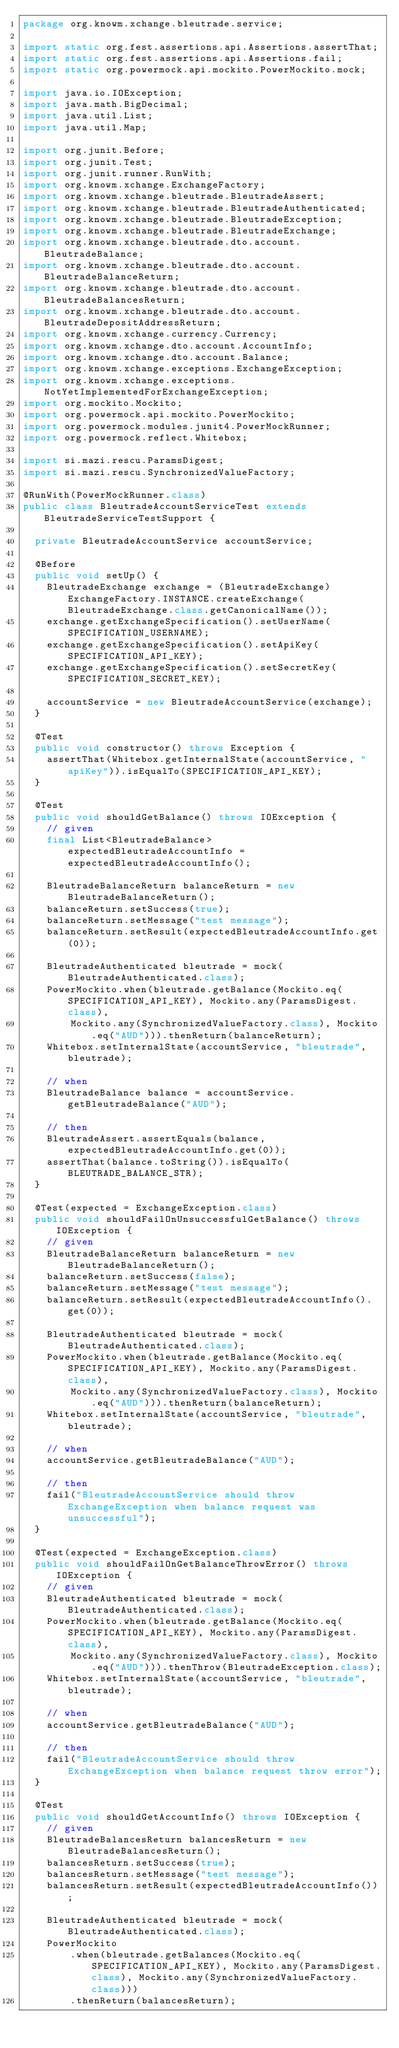<code> <loc_0><loc_0><loc_500><loc_500><_Java_>package org.knowm.xchange.bleutrade.service;

import static org.fest.assertions.api.Assertions.assertThat;
import static org.fest.assertions.api.Assertions.fail;
import static org.powermock.api.mockito.PowerMockito.mock;

import java.io.IOException;
import java.math.BigDecimal;
import java.util.List;
import java.util.Map;

import org.junit.Before;
import org.junit.Test;
import org.junit.runner.RunWith;
import org.knowm.xchange.ExchangeFactory;
import org.knowm.xchange.bleutrade.BleutradeAssert;
import org.knowm.xchange.bleutrade.BleutradeAuthenticated;
import org.knowm.xchange.bleutrade.BleutradeException;
import org.knowm.xchange.bleutrade.BleutradeExchange;
import org.knowm.xchange.bleutrade.dto.account.BleutradeBalance;
import org.knowm.xchange.bleutrade.dto.account.BleutradeBalanceReturn;
import org.knowm.xchange.bleutrade.dto.account.BleutradeBalancesReturn;
import org.knowm.xchange.bleutrade.dto.account.BleutradeDepositAddressReturn;
import org.knowm.xchange.currency.Currency;
import org.knowm.xchange.dto.account.AccountInfo;
import org.knowm.xchange.dto.account.Balance;
import org.knowm.xchange.exceptions.ExchangeException;
import org.knowm.xchange.exceptions.NotYetImplementedForExchangeException;
import org.mockito.Mockito;
import org.powermock.api.mockito.PowerMockito;
import org.powermock.modules.junit4.PowerMockRunner;
import org.powermock.reflect.Whitebox;

import si.mazi.rescu.ParamsDigest;
import si.mazi.rescu.SynchronizedValueFactory;

@RunWith(PowerMockRunner.class)
public class BleutradeAccountServiceTest extends BleutradeServiceTestSupport {

  private BleutradeAccountService accountService;

  @Before
  public void setUp() {
    BleutradeExchange exchange = (BleutradeExchange) ExchangeFactory.INSTANCE.createExchange(BleutradeExchange.class.getCanonicalName());
    exchange.getExchangeSpecification().setUserName(SPECIFICATION_USERNAME);
    exchange.getExchangeSpecification().setApiKey(SPECIFICATION_API_KEY);
    exchange.getExchangeSpecification().setSecretKey(SPECIFICATION_SECRET_KEY);

    accountService = new BleutradeAccountService(exchange);
  }

  @Test
  public void constructor() throws Exception {
    assertThat(Whitebox.getInternalState(accountService, "apiKey")).isEqualTo(SPECIFICATION_API_KEY);
  }

  @Test
  public void shouldGetBalance() throws IOException {
    // given
    final List<BleutradeBalance> expectedBleutradeAccountInfo = expectedBleutradeAccountInfo();

    BleutradeBalanceReturn balanceReturn = new BleutradeBalanceReturn();
    balanceReturn.setSuccess(true);
    balanceReturn.setMessage("test message");
    balanceReturn.setResult(expectedBleutradeAccountInfo.get(0));

    BleutradeAuthenticated bleutrade = mock(BleutradeAuthenticated.class);
    PowerMockito.when(bleutrade.getBalance(Mockito.eq(SPECIFICATION_API_KEY), Mockito.any(ParamsDigest.class),
        Mockito.any(SynchronizedValueFactory.class), Mockito.eq("AUD"))).thenReturn(balanceReturn);
    Whitebox.setInternalState(accountService, "bleutrade", bleutrade);

    // when
    BleutradeBalance balance = accountService.getBleutradeBalance("AUD");

    // then
    BleutradeAssert.assertEquals(balance, expectedBleutradeAccountInfo.get(0));
    assertThat(balance.toString()).isEqualTo(BLEUTRADE_BALANCE_STR);
  }

  @Test(expected = ExchangeException.class)
  public void shouldFailOnUnsuccessfulGetBalance() throws IOException {
    // given
    BleutradeBalanceReturn balanceReturn = new BleutradeBalanceReturn();
    balanceReturn.setSuccess(false);
    balanceReturn.setMessage("test message");
    balanceReturn.setResult(expectedBleutradeAccountInfo().get(0));

    BleutradeAuthenticated bleutrade = mock(BleutradeAuthenticated.class);
    PowerMockito.when(bleutrade.getBalance(Mockito.eq(SPECIFICATION_API_KEY), Mockito.any(ParamsDigest.class),
        Mockito.any(SynchronizedValueFactory.class), Mockito.eq("AUD"))).thenReturn(balanceReturn);
    Whitebox.setInternalState(accountService, "bleutrade", bleutrade);

    // when
    accountService.getBleutradeBalance("AUD");

    // then
    fail("BleutradeAccountService should throw ExchangeException when balance request was unsuccessful");
  }

  @Test(expected = ExchangeException.class)
  public void shouldFailOnGetBalanceThrowError() throws IOException {
    // given
    BleutradeAuthenticated bleutrade = mock(BleutradeAuthenticated.class);
    PowerMockito.when(bleutrade.getBalance(Mockito.eq(SPECIFICATION_API_KEY), Mockito.any(ParamsDigest.class),
        Mockito.any(SynchronizedValueFactory.class), Mockito.eq("AUD"))).thenThrow(BleutradeException.class);
    Whitebox.setInternalState(accountService, "bleutrade", bleutrade);

    // when
    accountService.getBleutradeBalance("AUD");

    // then
    fail("BleutradeAccountService should throw ExchangeException when balance request throw error");
  }

  @Test
  public void shouldGetAccountInfo() throws IOException {
    // given
    BleutradeBalancesReturn balancesReturn = new BleutradeBalancesReturn();
    balancesReturn.setSuccess(true);
    balancesReturn.setMessage("test message");
    balancesReturn.setResult(expectedBleutradeAccountInfo());

    BleutradeAuthenticated bleutrade = mock(BleutradeAuthenticated.class);
    PowerMockito
        .when(bleutrade.getBalances(Mockito.eq(SPECIFICATION_API_KEY), Mockito.any(ParamsDigest.class), Mockito.any(SynchronizedValueFactory.class)))
        .thenReturn(balancesReturn);</code> 